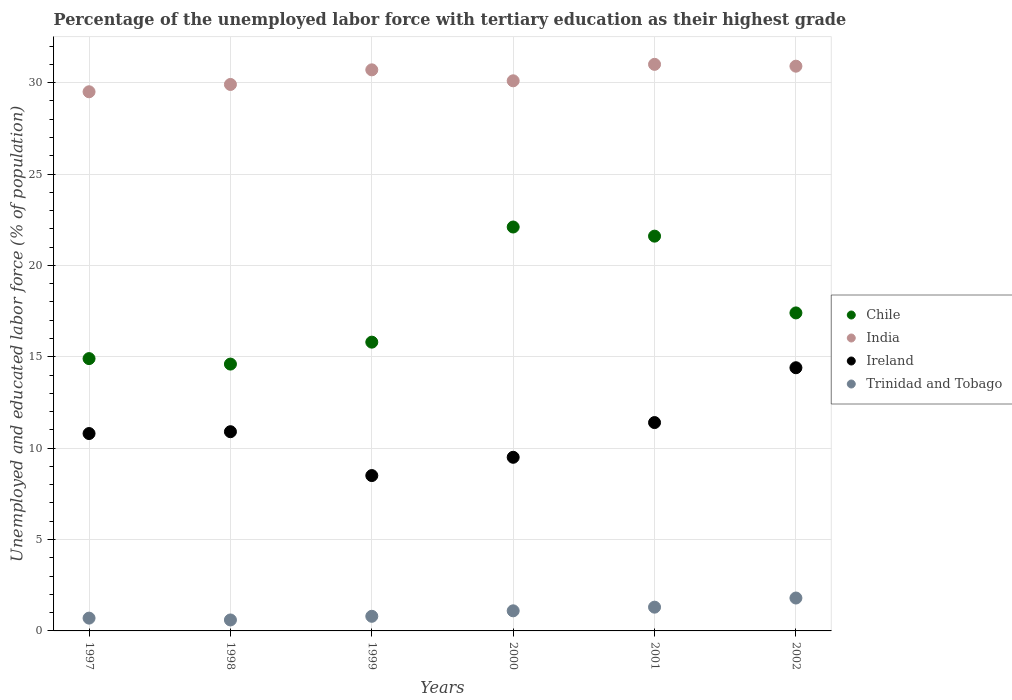What is the percentage of the unemployed labor force with tertiary education in Ireland in 2002?
Give a very brief answer. 14.4. Across all years, what is the minimum percentage of the unemployed labor force with tertiary education in India?
Your response must be concise. 29.5. In which year was the percentage of the unemployed labor force with tertiary education in Trinidad and Tobago maximum?
Provide a short and direct response. 2002. What is the total percentage of the unemployed labor force with tertiary education in Ireland in the graph?
Provide a succinct answer. 65.5. What is the difference between the percentage of the unemployed labor force with tertiary education in Trinidad and Tobago in 2000 and that in 2001?
Give a very brief answer. -0.2. What is the difference between the percentage of the unemployed labor force with tertiary education in Chile in 1999 and the percentage of the unemployed labor force with tertiary education in India in 2000?
Provide a succinct answer. -14.3. What is the average percentage of the unemployed labor force with tertiary education in India per year?
Offer a very short reply. 30.35. In the year 2000, what is the difference between the percentage of the unemployed labor force with tertiary education in Chile and percentage of the unemployed labor force with tertiary education in Ireland?
Keep it short and to the point. 12.6. In how many years, is the percentage of the unemployed labor force with tertiary education in Trinidad and Tobago greater than 21 %?
Your answer should be very brief. 0. What is the ratio of the percentage of the unemployed labor force with tertiary education in Ireland in 1999 to that in 2002?
Your answer should be compact. 0.59. Is the percentage of the unemployed labor force with tertiary education in Chile in 1997 less than that in 1998?
Provide a short and direct response. No. Is the difference between the percentage of the unemployed labor force with tertiary education in Chile in 1997 and 2002 greater than the difference between the percentage of the unemployed labor force with tertiary education in Ireland in 1997 and 2002?
Give a very brief answer. Yes. What is the difference between the highest and the second highest percentage of the unemployed labor force with tertiary education in India?
Your answer should be compact. 0.1. What is the difference between the highest and the lowest percentage of the unemployed labor force with tertiary education in Chile?
Your response must be concise. 7.5. Is it the case that in every year, the sum of the percentage of the unemployed labor force with tertiary education in Trinidad and Tobago and percentage of the unemployed labor force with tertiary education in Ireland  is greater than the sum of percentage of the unemployed labor force with tertiary education in Chile and percentage of the unemployed labor force with tertiary education in India?
Offer a very short reply. No. Is it the case that in every year, the sum of the percentage of the unemployed labor force with tertiary education in Ireland and percentage of the unemployed labor force with tertiary education in India  is greater than the percentage of the unemployed labor force with tertiary education in Chile?
Offer a very short reply. Yes. Does the percentage of the unemployed labor force with tertiary education in Chile monotonically increase over the years?
Provide a succinct answer. No. Is the percentage of the unemployed labor force with tertiary education in Chile strictly less than the percentage of the unemployed labor force with tertiary education in Ireland over the years?
Your response must be concise. No. How many years are there in the graph?
Ensure brevity in your answer.  6. What is the difference between two consecutive major ticks on the Y-axis?
Your response must be concise. 5. Where does the legend appear in the graph?
Make the answer very short. Center right. How are the legend labels stacked?
Offer a very short reply. Vertical. What is the title of the graph?
Offer a terse response. Percentage of the unemployed labor force with tertiary education as their highest grade. What is the label or title of the Y-axis?
Provide a short and direct response. Unemployed and educated labor force (% of population). What is the Unemployed and educated labor force (% of population) in Chile in 1997?
Offer a terse response. 14.9. What is the Unemployed and educated labor force (% of population) in India in 1997?
Provide a short and direct response. 29.5. What is the Unemployed and educated labor force (% of population) of Ireland in 1997?
Ensure brevity in your answer.  10.8. What is the Unemployed and educated labor force (% of population) in Trinidad and Tobago in 1997?
Your response must be concise. 0.7. What is the Unemployed and educated labor force (% of population) in Chile in 1998?
Your answer should be very brief. 14.6. What is the Unemployed and educated labor force (% of population) in India in 1998?
Make the answer very short. 29.9. What is the Unemployed and educated labor force (% of population) in Ireland in 1998?
Your answer should be very brief. 10.9. What is the Unemployed and educated labor force (% of population) of Trinidad and Tobago in 1998?
Provide a succinct answer. 0.6. What is the Unemployed and educated labor force (% of population) in Chile in 1999?
Make the answer very short. 15.8. What is the Unemployed and educated labor force (% of population) in India in 1999?
Your answer should be compact. 30.7. What is the Unemployed and educated labor force (% of population) of Ireland in 1999?
Ensure brevity in your answer.  8.5. What is the Unemployed and educated labor force (% of population) of Trinidad and Tobago in 1999?
Ensure brevity in your answer.  0.8. What is the Unemployed and educated labor force (% of population) of Chile in 2000?
Keep it short and to the point. 22.1. What is the Unemployed and educated labor force (% of population) of India in 2000?
Provide a succinct answer. 30.1. What is the Unemployed and educated labor force (% of population) of Trinidad and Tobago in 2000?
Your answer should be very brief. 1.1. What is the Unemployed and educated labor force (% of population) of Chile in 2001?
Provide a succinct answer. 21.6. What is the Unemployed and educated labor force (% of population) in Ireland in 2001?
Your answer should be very brief. 11.4. What is the Unemployed and educated labor force (% of population) of Trinidad and Tobago in 2001?
Give a very brief answer. 1.3. What is the Unemployed and educated labor force (% of population) of Chile in 2002?
Your answer should be compact. 17.4. What is the Unemployed and educated labor force (% of population) in India in 2002?
Offer a terse response. 30.9. What is the Unemployed and educated labor force (% of population) in Ireland in 2002?
Your answer should be compact. 14.4. What is the Unemployed and educated labor force (% of population) of Trinidad and Tobago in 2002?
Make the answer very short. 1.8. Across all years, what is the maximum Unemployed and educated labor force (% of population) of Chile?
Provide a succinct answer. 22.1. Across all years, what is the maximum Unemployed and educated labor force (% of population) in Ireland?
Give a very brief answer. 14.4. Across all years, what is the maximum Unemployed and educated labor force (% of population) in Trinidad and Tobago?
Offer a very short reply. 1.8. Across all years, what is the minimum Unemployed and educated labor force (% of population) of Chile?
Ensure brevity in your answer.  14.6. Across all years, what is the minimum Unemployed and educated labor force (% of population) in India?
Your answer should be compact. 29.5. Across all years, what is the minimum Unemployed and educated labor force (% of population) in Trinidad and Tobago?
Ensure brevity in your answer.  0.6. What is the total Unemployed and educated labor force (% of population) of Chile in the graph?
Ensure brevity in your answer.  106.4. What is the total Unemployed and educated labor force (% of population) of India in the graph?
Keep it short and to the point. 182.1. What is the total Unemployed and educated labor force (% of population) in Ireland in the graph?
Keep it short and to the point. 65.5. What is the difference between the Unemployed and educated labor force (% of population) of India in 1997 and that in 1998?
Ensure brevity in your answer.  -0.4. What is the difference between the Unemployed and educated labor force (% of population) of Trinidad and Tobago in 1997 and that in 1998?
Offer a very short reply. 0.1. What is the difference between the Unemployed and educated labor force (% of population) in Ireland in 1997 and that in 1999?
Make the answer very short. 2.3. What is the difference between the Unemployed and educated labor force (% of population) in Chile in 1997 and that in 2000?
Offer a terse response. -7.2. What is the difference between the Unemployed and educated labor force (% of population) of India in 1997 and that in 2000?
Provide a succinct answer. -0.6. What is the difference between the Unemployed and educated labor force (% of population) in Trinidad and Tobago in 1997 and that in 2000?
Offer a very short reply. -0.4. What is the difference between the Unemployed and educated labor force (% of population) of Chile in 1997 and that in 2001?
Your answer should be very brief. -6.7. What is the difference between the Unemployed and educated labor force (% of population) of Trinidad and Tobago in 1997 and that in 2001?
Make the answer very short. -0.6. What is the difference between the Unemployed and educated labor force (% of population) in Trinidad and Tobago in 1997 and that in 2002?
Your answer should be very brief. -1.1. What is the difference between the Unemployed and educated labor force (% of population) of India in 1998 and that in 1999?
Offer a terse response. -0.8. What is the difference between the Unemployed and educated labor force (% of population) in Ireland in 1998 and that in 1999?
Provide a succinct answer. 2.4. What is the difference between the Unemployed and educated labor force (% of population) in Trinidad and Tobago in 1998 and that in 1999?
Give a very brief answer. -0.2. What is the difference between the Unemployed and educated labor force (% of population) in India in 1998 and that in 2000?
Offer a very short reply. -0.2. What is the difference between the Unemployed and educated labor force (% of population) of Chile in 1998 and that in 2001?
Your response must be concise. -7. What is the difference between the Unemployed and educated labor force (% of population) in Ireland in 1998 and that in 2001?
Offer a very short reply. -0.5. What is the difference between the Unemployed and educated labor force (% of population) of Chile in 1998 and that in 2002?
Provide a succinct answer. -2.8. What is the difference between the Unemployed and educated labor force (% of population) in Ireland in 1998 and that in 2002?
Provide a succinct answer. -3.5. What is the difference between the Unemployed and educated labor force (% of population) of India in 1999 and that in 2000?
Your response must be concise. 0.6. What is the difference between the Unemployed and educated labor force (% of population) in Ireland in 1999 and that in 2000?
Make the answer very short. -1. What is the difference between the Unemployed and educated labor force (% of population) in Trinidad and Tobago in 1999 and that in 2000?
Make the answer very short. -0.3. What is the difference between the Unemployed and educated labor force (% of population) in India in 1999 and that in 2001?
Offer a very short reply. -0.3. What is the difference between the Unemployed and educated labor force (% of population) of Trinidad and Tobago in 1999 and that in 2002?
Offer a terse response. -1. What is the difference between the Unemployed and educated labor force (% of population) in India in 2000 and that in 2001?
Your answer should be very brief. -0.9. What is the difference between the Unemployed and educated labor force (% of population) in Ireland in 2000 and that in 2001?
Keep it short and to the point. -1.9. What is the difference between the Unemployed and educated labor force (% of population) in Trinidad and Tobago in 2000 and that in 2001?
Your answer should be very brief. -0.2. What is the difference between the Unemployed and educated labor force (% of population) of India in 2001 and that in 2002?
Your answer should be compact. 0.1. What is the difference between the Unemployed and educated labor force (% of population) in Trinidad and Tobago in 2001 and that in 2002?
Keep it short and to the point. -0.5. What is the difference between the Unemployed and educated labor force (% of population) of Chile in 1997 and the Unemployed and educated labor force (% of population) of India in 1998?
Provide a succinct answer. -15. What is the difference between the Unemployed and educated labor force (% of population) in Chile in 1997 and the Unemployed and educated labor force (% of population) in Ireland in 1998?
Give a very brief answer. 4. What is the difference between the Unemployed and educated labor force (% of population) of India in 1997 and the Unemployed and educated labor force (% of population) of Trinidad and Tobago in 1998?
Provide a short and direct response. 28.9. What is the difference between the Unemployed and educated labor force (% of population) of Chile in 1997 and the Unemployed and educated labor force (% of population) of India in 1999?
Give a very brief answer. -15.8. What is the difference between the Unemployed and educated labor force (% of population) of Chile in 1997 and the Unemployed and educated labor force (% of population) of Ireland in 1999?
Make the answer very short. 6.4. What is the difference between the Unemployed and educated labor force (% of population) of Chile in 1997 and the Unemployed and educated labor force (% of population) of Trinidad and Tobago in 1999?
Give a very brief answer. 14.1. What is the difference between the Unemployed and educated labor force (% of population) of India in 1997 and the Unemployed and educated labor force (% of population) of Ireland in 1999?
Your answer should be very brief. 21. What is the difference between the Unemployed and educated labor force (% of population) of India in 1997 and the Unemployed and educated labor force (% of population) of Trinidad and Tobago in 1999?
Make the answer very short. 28.7. What is the difference between the Unemployed and educated labor force (% of population) in Chile in 1997 and the Unemployed and educated labor force (% of population) in India in 2000?
Your answer should be compact. -15.2. What is the difference between the Unemployed and educated labor force (% of population) of Chile in 1997 and the Unemployed and educated labor force (% of population) of Trinidad and Tobago in 2000?
Give a very brief answer. 13.8. What is the difference between the Unemployed and educated labor force (% of population) in India in 1997 and the Unemployed and educated labor force (% of population) in Ireland in 2000?
Give a very brief answer. 20. What is the difference between the Unemployed and educated labor force (% of population) of India in 1997 and the Unemployed and educated labor force (% of population) of Trinidad and Tobago in 2000?
Your response must be concise. 28.4. What is the difference between the Unemployed and educated labor force (% of population) in Ireland in 1997 and the Unemployed and educated labor force (% of population) in Trinidad and Tobago in 2000?
Offer a terse response. 9.7. What is the difference between the Unemployed and educated labor force (% of population) in Chile in 1997 and the Unemployed and educated labor force (% of population) in India in 2001?
Offer a terse response. -16.1. What is the difference between the Unemployed and educated labor force (% of population) in Chile in 1997 and the Unemployed and educated labor force (% of population) in Ireland in 2001?
Keep it short and to the point. 3.5. What is the difference between the Unemployed and educated labor force (% of population) in India in 1997 and the Unemployed and educated labor force (% of population) in Ireland in 2001?
Provide a succinct answer. 18.1. What is the difference between the Unemployed and educated labor force (% of population) in India in 1997 and the Unemployed and educated labor force (% of population) in Trinidad and Tobago in 2001?
Keep it short and to the point. 28.2. What is the difference between the Unemployed and educated labor force (% of population) of Chile in 1997 and the Unemployed and educated labor force (% of population) of India in 2002?
Offer a very short reply. -16. What is the difference between the Unemployed and educated labor force (% of population) in Chile in 1997 and the Unemployed and educated labor force (% of population) in Ireland in 2002?
Offer a very short reply. 0.5. What is the difference between the Unemployed and educated labor force (% of population) in Chile in 1997 and the Unemployed and educated labor force (% of population) in Trinidad and Tobago in 2002?
Offer a very short reply. 13.1. What is the difference between the Unemployed and educated labor force (% of population) of India in 1997 and the Unemployed and educated labor force (% of population) of Trinidad and Tobago in 2002?
Make the answer very short. 27.7. What is the difference between the Unemployed and educated labor force (% of population) of Ireland in 1997 and the Unemployed and educated labor force (% of population) of Trinidad and Tobago in 2002?
Provide a short and direct response. 9. What is the difference between the Unemployed and educated labor force (% of population) of Chile in 1998 and the Unemployed and educated labor force (% of population) of India in 1999?
Keep it short and to the point. -16.1. What is the difference between the Unemployed and educated labor force (% of population) in Chile in 1998 and the Unemployed and educated labor force (% of population) in Ireland in 1999?
Your answer should be very brief. 6.1. What is the difference between the Unemployed and educated labor force (% of population) of Chile in 1998 and the Unemployed and educated labor force (% of population) of Trinidad and Tobago in 1999?
Offer a terse response. 13.8. What is the difference between the Unemployed and educated labor force (% of population) of India in 1998 and the Unemployed and educated labor force (% of population) of Ireland in 1999?
Offer a very short reply. 21.4. What is the difference between the Unemployed and educated labor force (% of population) in India in 1998 and the Unemployed and educated labor force (% of population) in Trinidad and Tobago in 1999?
Provide a succinct answer. 29.1. What is the difference between the Unemployed and educated labor force (% of population) in Chile in 1998 and the Unemployed and educated labor force (% of population) in India in 2000?
Offer a very short reply. -15.5. What is the difference between the Unemployed and educated labor force (% of population) of Chile in 1998 and the Unemployed and educated labor force (% of population) of Ireland in 2000?
Provide a succinct answer. 5.1. What is the difference between the Unemployed and educated labor force (% of population) in India in 1998 and the Unemployed and educated labor force (% of population) in Ireland in 2000?
Give a very brief answer. 20.4. What is the difference between the Unemployed and educated labor force (% of population) in India in 1998 and the Unemployed and educated labor force (% of population) in Trinidad and Tobago in 2000?
Keep it short and to the point. 28.8. What is the difference between the Unemployed and educated labor force (% of population) in Ireland in 1998 and the Unemployed and educated labor force (% of population) in Trinidad and Tobago in 2000?
Provide a succinct answer. 9.8. What is the difference between the Unemployed and educated labor force (% of population) of Chile in 1998 and the Unemployed and educated labor force (% of population) of India in 2001?
Your answer should be compact. -16.4. What is the difference between the Unemployed and educated labor force (% of population) of Chile in 1998 and the Unemployed and educated labor force (% of population) of Trinidad and Tobago in 2001?
Ensure brevity in your answer.  13.3. What is the difference between the Unemployed and educated labor force (% of population) of India in 1998 and the Unemployed and educated labor force (% of population) of Ireland in 2001?
Your answer should be compact. 18.5. What is the difference between the Unemployed and educated labor force (% of population) of India in 1998 and the Unemployed and educated labor force (% of population) of Trinidad and Tobago in 2001?
Keep it short and to the point. 28.6. What is the difference between the Unemployed and educated labor force (% of population) of Ireland in 1998 and the Unemployed and educated labor force (% of population) of Trinidad and Tobago in 2001?
Your answer should be very brief. 9.6. What is the difference between the Unemployed and educated labor force (% of population) of Chile in 1998 and the Unemployed and educated labor force (% of population) of India in 2002?
Give a very brief answer. -16.3. What is the difference between the Unemployed and educated labor force (% of population) of Chile in 1998 and the Unemployed and educated labor force (% of population) of Trinidad and Tobago in 2002?
Provide a succinct answer. 12.8. What is the difference between the Unemployed and educated labor force (% of population) in India in 1998 and the Unemployed and educated labor force (% of population) in Ireland in 2002?
Give a very brief answer. 15.5. What is the difference between the Unemployed and educated labor force (% of population) in India in 1998 and the Unemployed and educated labor force (% of population) in Trinidad and Tobago in 2002?
Make the answer very short. 28.1. What is the difference between the Unemployed and educated labor force (% of population) of Ireland in 1998 and the Unemployed and educated labor force (% of population) of Trinidad and Tobago in 2002?
Ensure brevity in your answer.  9.1. What is the difference between the Unemployed and educated labor force (% of population) of Chile in 1999 and the Unemployed and educated labor force (% of population) of India in 2000?
Provide a succinct answer. -14.3. What is the difference between the Unemployed and educated labor force (% of population) of Chile in 1999 and the Unemployed and educated labor force (% of population) of Ireland in 2000?
Your response must be concise. 6.3. What is the difference between the Unemployed and educated labor force (% of population) in India in 1999 and the Unemployed and educated labor force (% of population) in Ireland in 2000?
Offer a terse response. 21.2. What is the difference between the Unemployed and educated labor force (% of population) in India in 1999 and the Unemployed and educated labor force (% of population) in Trinidad and Tobago in 2000?
Make the answer very short. 29.6. What is the difference between the Unemployed and educated labor force (% of population) of Ireland in 1999 and the Unemployed and educated labor force (% of population) of Trinidad and Tobago in 2000?
Provide a short and direct response. 7.4. What is the difference between the Unemployed and educated labor force (% of population) in Chile in 1999 and the Unemployed and educated labor force (% of population) in India in 2001?
Your answer should be very brief. -15.2. What is the difference between the Unemployed and educated labor force (% of population) of Chile in 1999 and the Unemployed and educated labor force (% of population) of Ireland in 2001?
Offer a very short reply. 4.4. What is the difference between the Unemployed and educated labor force (% of population) of Chile in 1999 and the Unemployed and educated labor force (% of population) of Trinidad and Tobago in 2001?
Provide a succinct answer. 14.5. What is the difference between the Unemployed and educated labor force (% of population) of India in 1999 and the Unemployed and educated labor force (% of population) of Ireland in 2001?
Provide a succinct answer. 19.3. What is the difference between the Unemployed and educated labor force (% of population) of India in 1999 and the Unemployed and educated labor force (% of population) of Trinidad and Tobago in 2001?
Keep it short and to the point. 29.4. What is the difference between the Unemployed and educated labor force (% of population) in Chile in 1999 and the Unemployed and educated labor force (% of population) in India in 2002?
Your answer should be compact. -15.1. What is the difference between the Unemployed and educated labor force (% of population) in Chile in 1999 and the Unemployed and educated labor force (% of population) in Ireland in 2002?
Your answer should be very brief. 1.4. What is the difference between the Unemployed and educated labor force (% of population) of India in 1999 and the Unemployed and educated labor force (% of population) of Ireland in 2002?
Make the answer very short. 16.3. What is the difference between the Unemployed and educated labor force (% of population) of India in 1999 and the Unemployed and educated labor force (% of population) of Trinidad and Tobago in 2002?
Keep it short and to the point. 28.9. What is the difference between the Unemployed and educated labor force (% of population) in Chile in 2000 and the Unemployed and educated labor force (% of population) in India in 2001?
Your answer should be compact. -8.9. What is the difference between the Unemployed and educated labor force (% of population) of Chile in 2000 and the Unemployed and educated labor force (% of population) of Ireland in 2001?
Offer a terse response. 10.7. What is the difference between the Unemployed and educated labor force (% of population) of Chile in 2000 and the Unemployed and educated labor force (% of population) of Trinidad and Tobago in 2001?
Provide a succinct answer. 20.8. What is the difference between the Unemployed and educated labor force (% of population) in India in 2000 and the Unemployed and educated labor force (% of population) in Ireland in 2001?
Your answer should be very brief. 18.7. What is the difference between the Unemployed and educated labor force (% of population) of India in 2000 and the Unemployed and educated labor force (% of population) of Trinidad and Tobago in 2001?
Provide a succinct answer. 28.8. What is the difference between the Unemployed and educated labor force (% of population) in Ireland in 2000 and the Unemployed and educated labor force (% of population) in Trinidad and Tobago in 2001?
Provide a succinct answer. 8.2. What is the difference between the Unemployed and educated labor force (% of population) in Chile in 2000 and the Unemployed and educated labor force (% of population) in India in 2002?
Give a very brief answer. -8.8. What is the difference between the Unemployed and educated labor force (% of population) of Chile in 2000 and the Unemployed and educated labor force (% of population) of Trinidad and Tobago in 2002?
Your answer should be very brief. 20.3. What is the difference between the Unemployed and educated labor force (% of population) of India in 2000 and the Unemployed and educated labor force (% of population) of Ireland in 2002?
Make the answer very short. 15.7. What is the difference between the Unemployed and educated labor force (% of population) of India in 2000 and the Unemployed and educated labor force (% of population) of Trinidad and Tobago in 2002?
Keep it short and to the point. 28.3. What is the difference between the Unemployed and educated labor force (% of population) in Ireland in 2000 and the Unemployed and educated labor force (% of population) in Trinidad and Tobago in 2002?
Your response must be concise. 7.7. What is the difference between the Unemployed and educated labor force (% of population) in Chile in 2001 and the Unemployed and educated labor force (% of population) in Trinidad and Tobago in 2002?
Offer a terse response. 19.8. What is the difference between the Unemployed and educated labor force (% of population) of India in 2001 and the Unemployed and educated labor force (% of population) of Trinidad and Tobago in 2002?
Offer a very short reply. 29.2. What is the average Unemployed and educated labor force (% of population) in Chile per year?
Your answer should be compact. 17.73. What is the average Unemployed and educated labor force (% of population) in India per year?
Make the answer very short. 30.35. What is the average Unemployed and educated labor force (% of population) of Ireland per year?
Offer a terse response. 10.92. What is the average Unemployed and educated labor force (% of population) of Trinidad and Tobago per year?
Your response must be concise. 1.05. In the year 1997, what is the difference between the Unemployed and educated labor force (% of population) of Chile and Unemployed and educated labor force (% of population) of India?
Your answer should be compact. -14.6. In the year 1997, what is the difference between the Unemployed and educated labor force (% of population) in India and Unemployed and educated labor force (% of population) in Trinidad and Tobago?
Your answer should be very brief. 28.8. In the year 1998, what is the difference between the Unemployed and educated labor force (% of population) in Chile and Unemployed and educated labor force (% of population) in India?
Provide a succinct answer. -15.3. In the year 1998, what is the difference between the Unemployed and educated labor force (% of population) of Chile and Unemployed and educated labor force (% of population) of Trinidad and Tobago?
Offer a very short reply. 14. In the year 1998, what is the difference between the Unemployed and educated labor force (% of population) of India and Unemployed and educated labor force (% of population) of Ireland?
Make the answer very short. 19. In the year 1998, what is the difference between the Unemployed and educated labor force (% of population) in India and Unemployed and educated labor force (% of population) in Trinidad and Tobago?
Your answer should be very brief. 29.3. In the year 1998, what is the difference between the Unemployed and educated labor force (% of population) in Ireland and Unemployed and educated labor force (% of population) in Trinidad and Tobago?
Keep it short and to the point. 10.3. In the year 1999, what is the difference between the Unemployed and educated labor force (% of population) of Chile and Unemployed and educated labor force (% of population) of India?
Offer a terse response. -14.9. In the year 1999, what is the difference between the Unemployed and educated labor force (% of population) in India and Unemployed and educated labor force (% of population) in Ireland?
Your answer should be compact. 22.2. In the year 1999, what is the difference between the Unemployed and educated labor force (% of population) in India and Unemployed and educated labor force (% of population) in Trinidad and Tobago?
Keep it short and to the point. 29.9. In the year 1999, what is the difference between the Unemployed and educated labor force (% of population) in Ireland and Unemployed and educated labor force (% of population) in Trinidad and Tobago?
Ensure brevity in your answer.  7.7. In the year 2000, what is the difference between the Unemployed and educated labor force (% of population) of Chile and Unemployed and educated labor force (% of population) of Ireland?
Your answer should be compact. 12.6. In the year 2000, what is the difference between the Unemployed and educated labor force (% of population) of India and Unemployed and educated labor force (% of population) of Ireland?
Make the answer very short. 20.6. In the year 2000, what is the difference between the Unemployed and educated labor force (% of population) of Ireland and Unemployed and educated labor force (% of population) of Trinidad and Tobago?
Your answer should be compact. 8.4. In the year 2001, what is the difference between the Unemployed and educated labor force (% of population) in Chile and Unemployed and educated labor force (% of population) in India?
Make the answer very short. -9.4. In the year 2001, what is the difference between the Unemployed and educated labor force (% of population) of Chile and Unemployed and educated labor force (% of population) of Trinidad and Tobago?
Your answer should be compact. 20.3. In the year 2001, what is the difference between the Unemployed and educated labor force (% of population) of India and Unemployed and educated labor force (% of population) of Ireland?
Provide a short and direct response. 19.6. In the year 2001, what is the difference between the Unemployed and educated labor force (% of population) of India and Unemployed and educated labor force (% of population) of Trinidad and Tobago?
Your answer should be compact. 29.7. In the year 2002, what is the difference between the Unemployed and educated labor force (% of population) in Chile and Unemployed and educated labor force (% of population) in India?
Give a very brief answer. -13.5. In the year 2002, what is the difference between the Unemployed and educated labor force (% of population) in Chile and Unemployed and educated labor force (% of population) in Ireland?
Make the answer very short. 3. In the year 2002, what is the difference between the Unemployed and educated labor force (% of population) of Chile and Unemployed and educated labor force (% of population) of Trinidad and Tobago?
Your answer should be very brief. 15.6. In the year 2002, what is the difference between the Unemployed and educated labor force (% of population) of India and Unemployed and educated labor force (% of population) of Trinidad and Tobago?
Offer a very short reply. 29.1. What is the ratio of the Unemployed and educated labor force (% of population) in Chile in 1997 to that in 1998?
Provide a succinct answer. 1.02. What is the ratio of the Unemployed and educated labor force (% of population) of India in 1997 to that in 1998?
Ensure brevity in your answer.  0.99. What is the ratio of the Unemployed and educated labor force (% of population) of Ireland in 1997 to that in 1998?
Give a very brief answer. 0.99. What is the ratio of the Unemployed and educated labor force (% of population) in Trinidad and Tobago in 1997 to that in 1998?
Offer a terse response. 1.17. What is the ratio of the Unemployed and educated labor force (% of population) of Chile in 1997 to that in 1999?
Offer a terse response. 0.94. What is the ratio of the Unemployed and educated labor force (% of population) of India in 1997 to that in 1999?
Provide a short and direct response. 0.96. What is the ratio of the Unemployed and educated labor force (% of population) in Ireland in 1997 to that in 1999?
Ensure brevity in your answer.  1.27. What is the ratio of the Unemployed and educated labor force (% of population) in Chile in 1997 to that in 2000?
Offer a terse response. 0.67. What is the ratio of the Unemployed and educated labor force (% of population) in India in 1997 to that in 2000?
Provide a short and direct response. 0.98. What is the ratio of the Unemployed and educated labor force (% of population) in Ireland in 1997 to that in 2000?
Give a very brief answer. 1.14. What is the ratio of the Unemployed and educated labor force (% of population) of Trinidad and Tobago in 1997 to that in 2000?
Make the answer very short. 0.64. What is the ratio of the Unemployed and educated labor force (% of population) in Chile in 1997 to that in 2001?
Your answer should be very brief. 0.69. What is the ratio of the Unemployed and educated labor force (% of population) in India in 1997 to that in 2001?
Your answer should be compact. 0.95. What is the ratio of the Unemployed and educated labor force (% of population) of Ireland in 1997 to that in 2001?
Provide a short and direct response. 0.95. What is the ratio of the Unemployed and educated labor force (% of population) in Trinidad and Tobago in 1997 to that in 2001?
Provide a short and direct response. 0.54. What is the ratio of the Unemployed and educated labor force (% of population) in Chile in 1997 to that in 2002?
Provide a short and direct response. 0.86. What is the ratio of the Unemployed and educated labor force (% of population) in India in 1997 to that in 2002?
Your answer should be compact. 0.95. What is the ratio of the Unemployed and educated labor force (% of population) in Ireland in 1997 to that in 2002?
Keep it short and to the point. 0.75. What is the ratio of the Unemployed and educated labor force (% of population) in Trinidad and Tobago in 1997 to that in 2002?
Provide a succinct answer. 0.39. What is the ratio of the Unemployed and educated labor force (% of population) in Chile in 1998 to that in 1999?
Provide a succinct answer. 0.92. What is the ratio of the Unemployed and educated labor force (% of population) in India in 1998 to that in 1999?
Provide a succinct answer. 0.97. What is the ratio of the Unemployed and educated labor force (% of population) in Ireland in 1998 to that in 1999?
Your answer should be compact. 1.28. What is the ratio of the Unemployed and educated labor force (% of population) of Chile in 1998 to that in 2000?
Your answer should be compact. 0.66. What is the ratio of the Unemployed and educated labor force (% of population) in Ireland in 1998 to that in 2000?
Give a very brief answer. 1.15. What is the ratio of the Unemployed and educated labor force (% of population) of Trinidad and Tobago in 1998 to that in 2000?
Make the answer very short. 0.55. What is the ratio of the Unemployed and educated labor force (% of population) in Chile in 1998 to that in 2001?
Provide a succinct answer. 0.68. What is the ratio of the Unemployed and educated labor force (% of population) in India in 1998 to that in 2001?
Ensure brevity in your answer.  0.96. What is the ratio of the Unemployed and educated labor force (% of population) of Ireland in 1998 to that in 2001?
Provide a short and direct response. 0.96. What is the ratio of the Unemployed and educated labor force (% of population) of Trinidad and Tobago in 1998 to that in 2001?
Your response must be concise. 0.46. What is the ratio of the Unemployed and educated labor force (% of population) of Chile in 1998 to that in 2002?
Provide a short and direct response. 0.84. What is the ratio of the Unemployed and educated labor force (% of population) of India in 1998 to that in 2002?
Your answer should be compact. 0.97. What is the ratio of the Unemployed and educated labor force (% of population) of Ireland in 1998 to that in 2002?
Provide a short and direct response. 0.76. What is the ratio of the Unemployed and educated labor force (% of population) of Chile in 1999 to that in 2000?
Your response must be concise. 0.71. What is the ratio of the Unemployed and educated labor force (% of population) in India in 1999 to that in 2000?
Offer a terse response. 1.02. What is the ratio of the Unemployed and educated labor force (% of population) in Ireland in 1999 to that in 2000?
Keep it short and to the point. 0.89. What is the ratio of the Unemployed and educated labor force (% of population) in Trinidad and Tobago in 1999 to that in 2000?
Make the answer very short. 0.73. What is the ratio of the Unemployed and educated labor force (% of population) in Chile in 1999 to that in 2001?
Keep it short and to the point. 0.73. What is the ratio of the Unemployed and educated labor force (% of population) in India in 1999 to that in 2001?
Provide a succinct answer. 0.99. What is the ratio of the Unemployed and educated labor force (% of population) in Ireland in 1999 to that in 2001?
Your response must be concise. 0.75. What is the ratio of the Unemployed and educated labor force (% of population) of Trinidad and Tobago in 1999 to that in 2001?
Make the answer very short. 0.62. What is the ratio of the Unemployed and educated labor force (% of population) in Chile in 1999 to that in 2002?
Offer a terse response. 0.91. What is the ratio of the Unemployed and educated labor force (% of population) in Ireland in 1999 to that in 2002?
Your response must be concise. 0.59. What is the ratio of the Unemployed and educated labor force (% of population) of Trinidad and Tobago in 1999 to that in 2002?
Offer a terse response. 0.44. What is the ratio of the Unemployed and educated labor force (% of population) of Chile in 2000 to that in 2001?
Your answer should be very brief. 1.02. What is the ratio of the Unemployed and educated labor force (% of population) in Trinidad and Tobago in 2000 to that in 2001?
Provide a succinct answer. 0.85. What is the ratio of the Unemployed and educated labor force (% of population) of Chile in 2000 to that in 2002?
Provide a short and direct response. 1.27. What is the ratio of the Unemployed and educated labor force (% of population) of India in 2000 to that in 2002?
Provide a succinct answer. 0.97. What is the ratio of the Unemployed and educated labor force (% of population) of Ireland in 2000 to that in 2002?
Make the answer very short. 0.66. What is the ratio of the Unemployed and educated labor force (% of population) of Trinidad and Tobago in 2000 to that in 2002?
Your response must be concise. 0.61. What is the ratio of the Unemployed and educated labor force (% of population) in Chile in 2001 to that in 2002?
Keep it short and to the point. 1.24. What is the ratio of the Unemployed and educated labor force (% of population) in India in 2001 to that in 2002?
Your answer should be very brief. 1. What is the ratio of the Unemployed and educated labor force (% of population) of Ireland in 2001 to that in 2002?
Make the answer very short. 0.79. What is the ratio of the Unemployed and educated labor force (% of population) in Trinidad and Tobago in 2001 to that in 2002?
Your answer should be very brief. 0.72. What is the difference between the highest and the second highest Unemployed and educated labor force (% of population) in Chile?
Offer a very short reply. 0.5. What is the difference between the highest and the second highest Unemployed and educated labor force (% of population) in India?
Ensure brevity in your answer.  0.1. What is the difference between the highest and the second highest Unemployed and educated labor force (% of population) of Trinidad and Tobago?
Provide a succinct answer. 0.5. What is the difference between the highest and the lowest Unemployed and educated labor force (% of population) of Chile?
Give a very brief answer. 7.5. What is the difference between the highest and the lowest Unemployed and educated labor force (% of population) of India?
Provide a short and direct response. 1.5. 